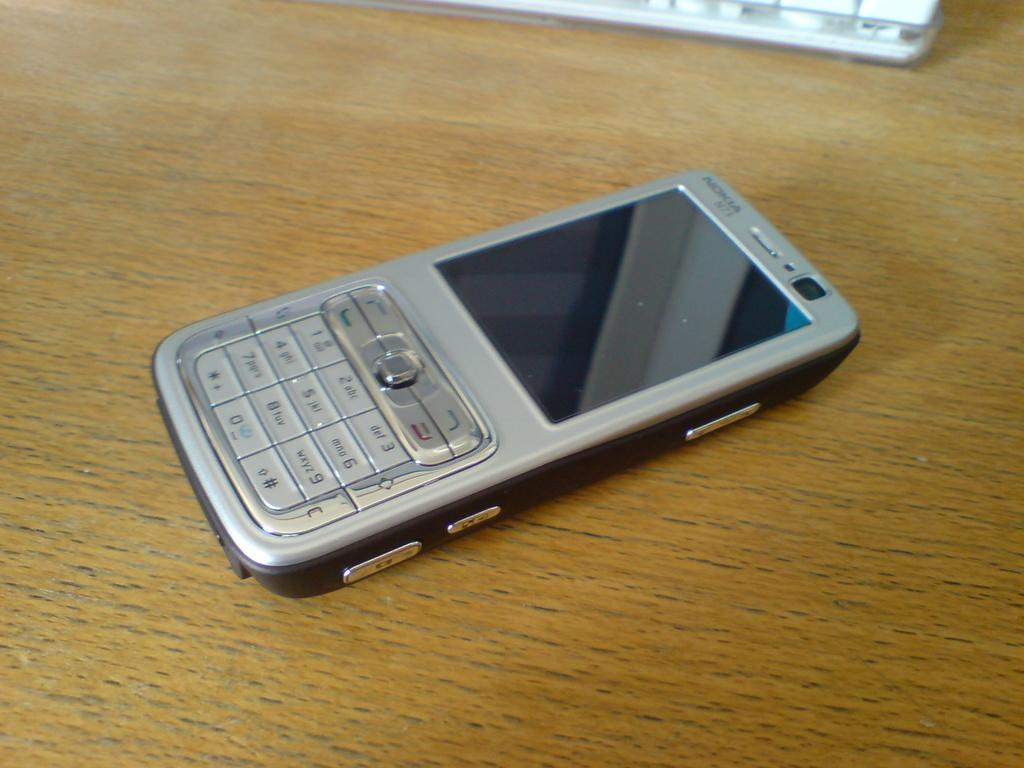<image>
Relay a brief, clear account of the picture shown. A Nokia cell phone rests on a wooden surface. 